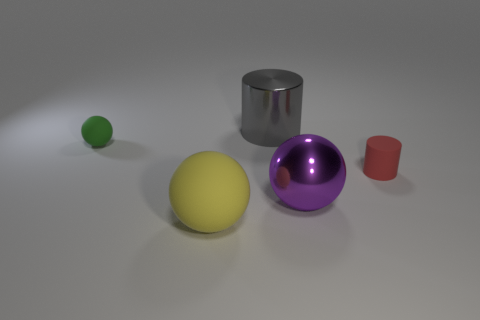Subtract all cyan spheres. Subtract all red cylinders. How many spheres are left? 3 Add 4 big yellow matte objects. How many objects exist? 9 Subtract all cylinders. How many objects are left? 3 Add 3 red matte cylinders. How many red matte cylinders are left? 4 Add 3 big gray balls. How many big gray balls exist? 3 Subtract 0 brown balls. How many objects are left? 5 Subtract all tiny red blocks. Subtract all small rubber things. How many objects are left? 3 